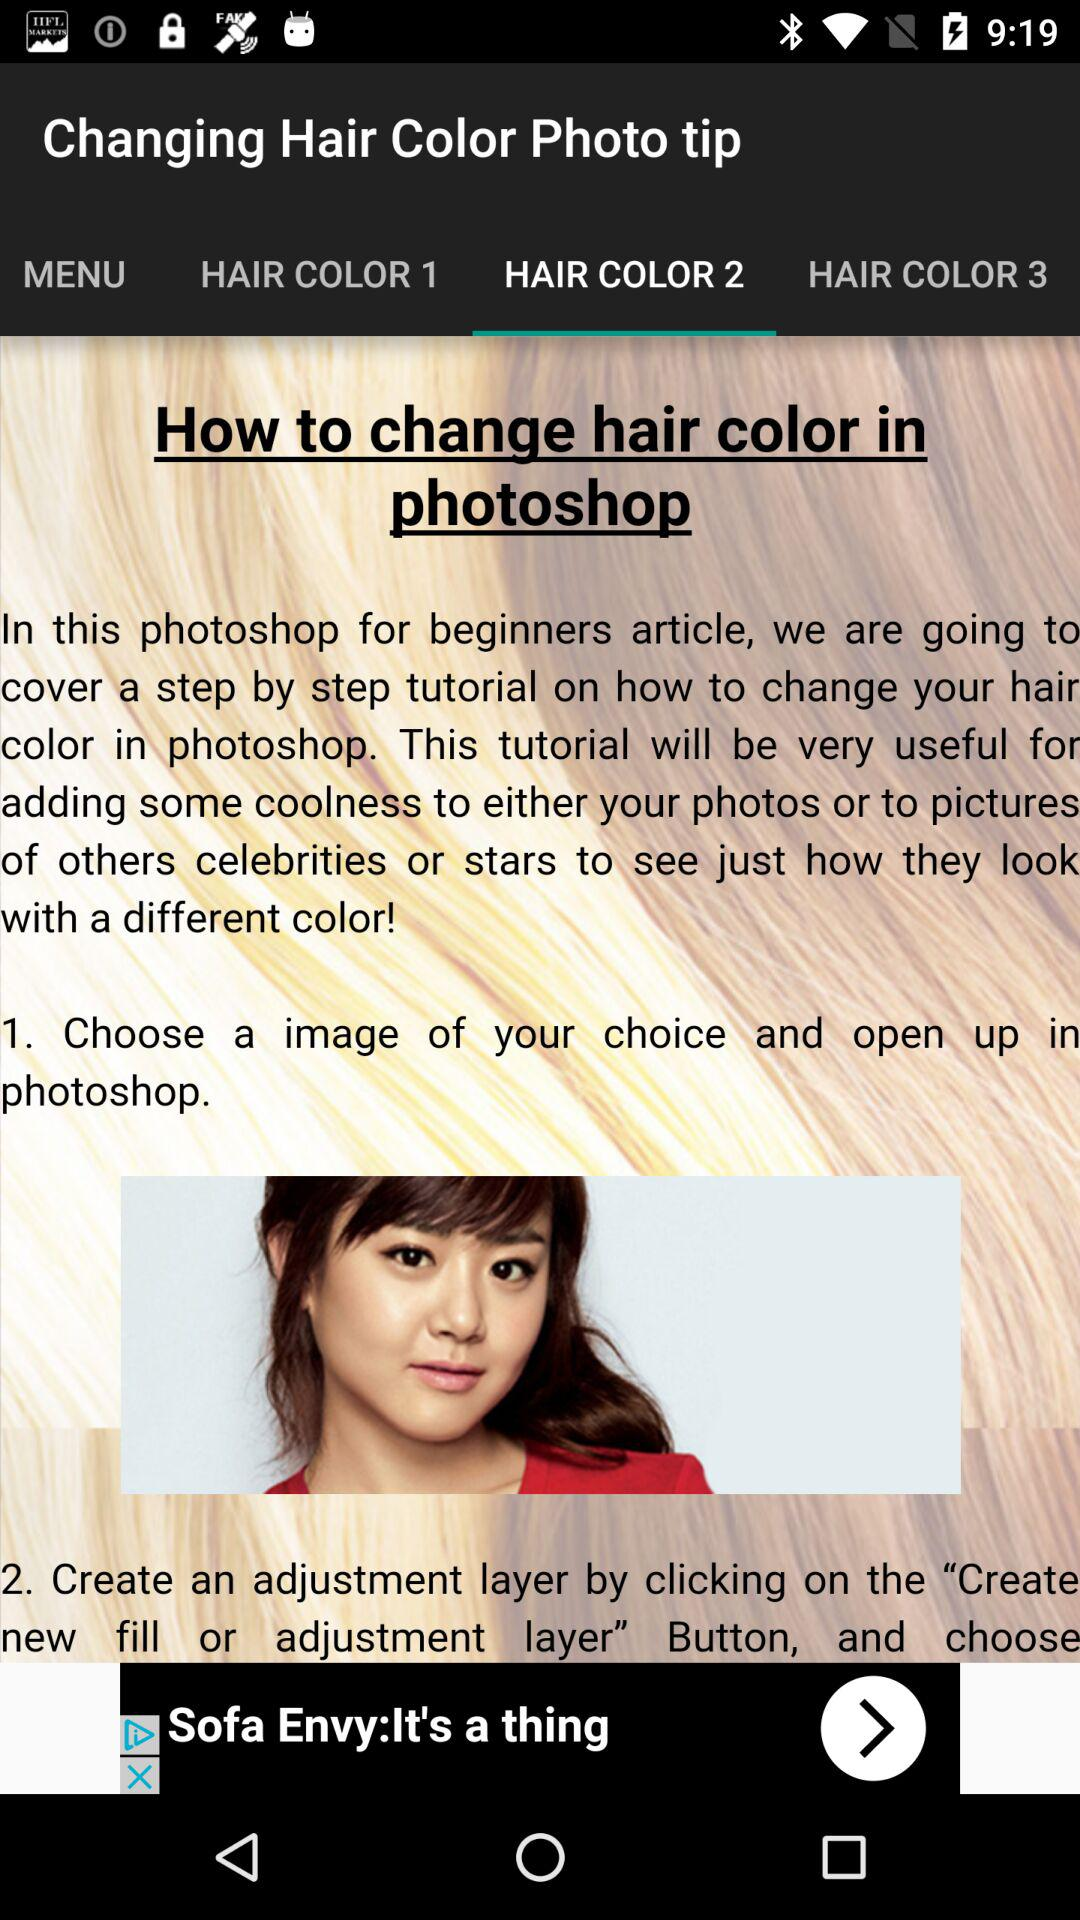What is the name of the topic? The name of the topic is "How to change hair color in photoshop". 